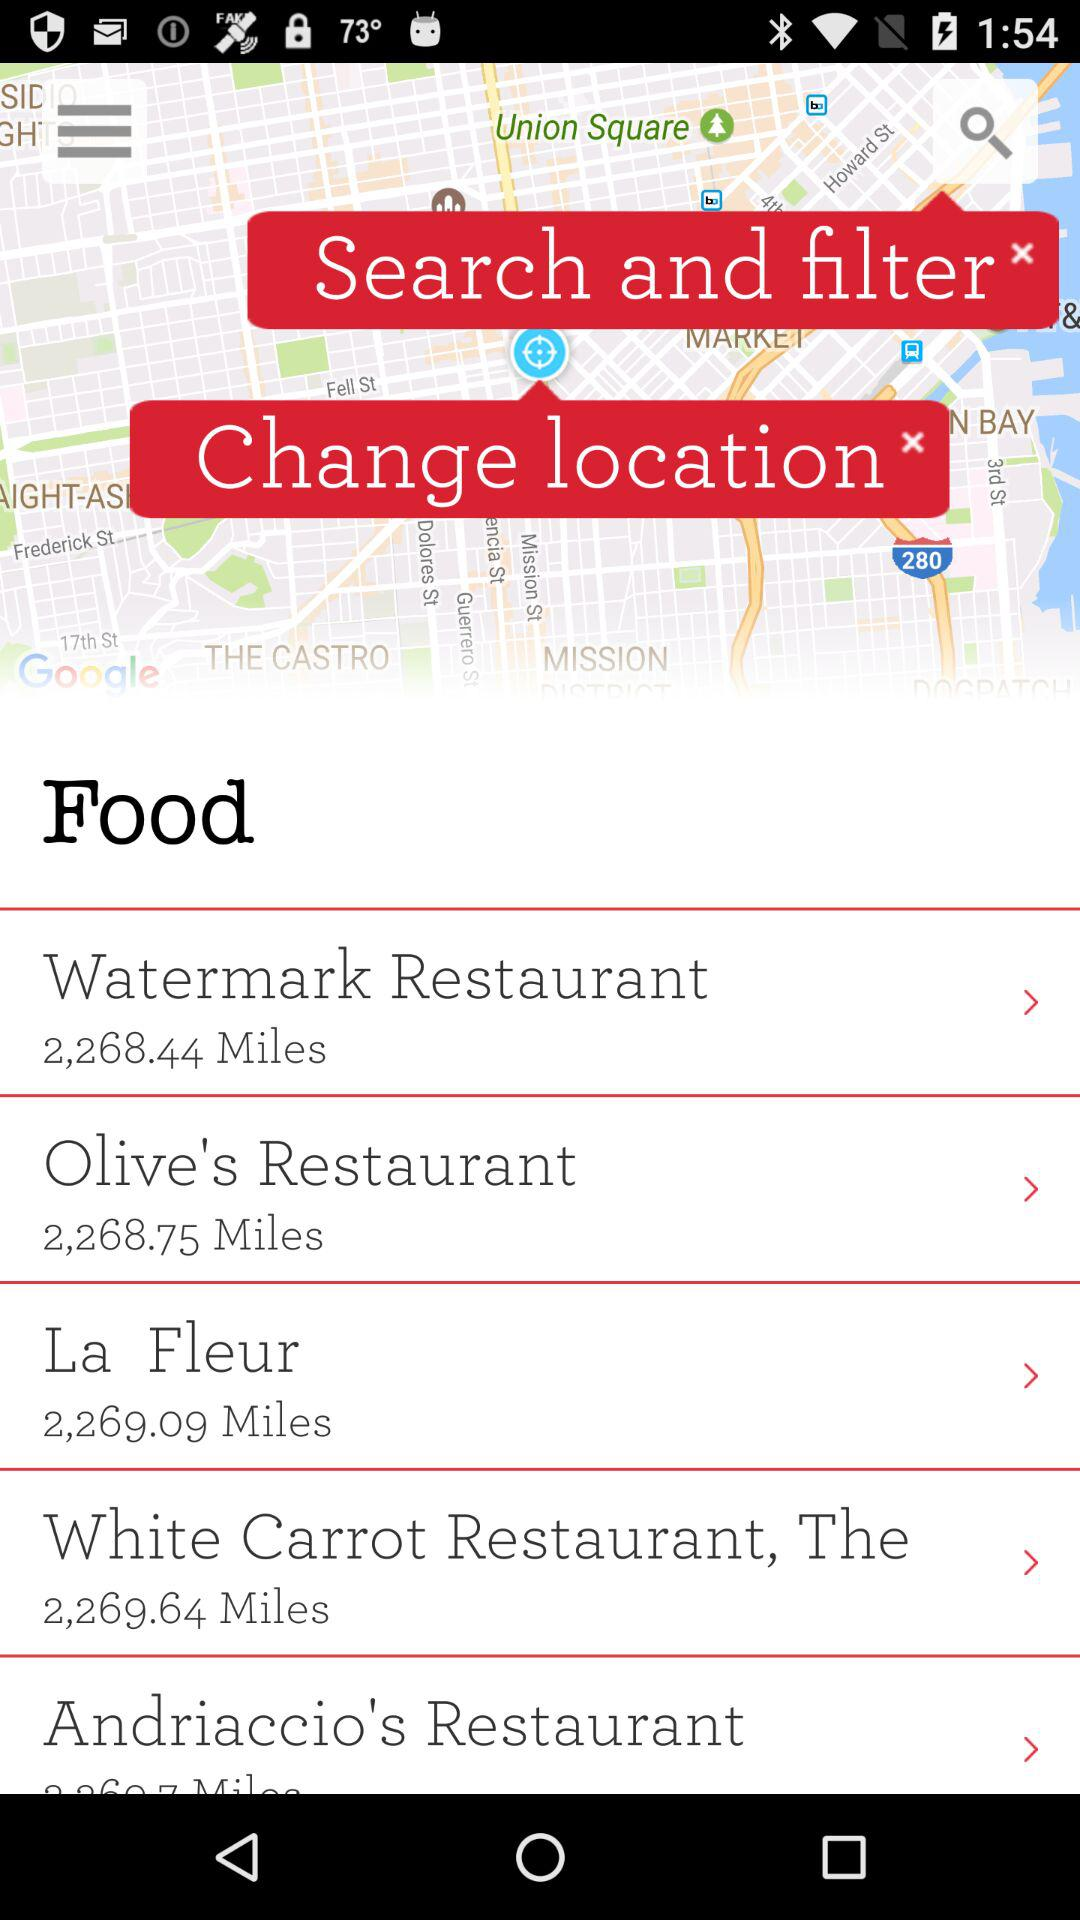What is the distance between "Watermark Restaurant" and where I am? The distance is 2,268.44 miles. 